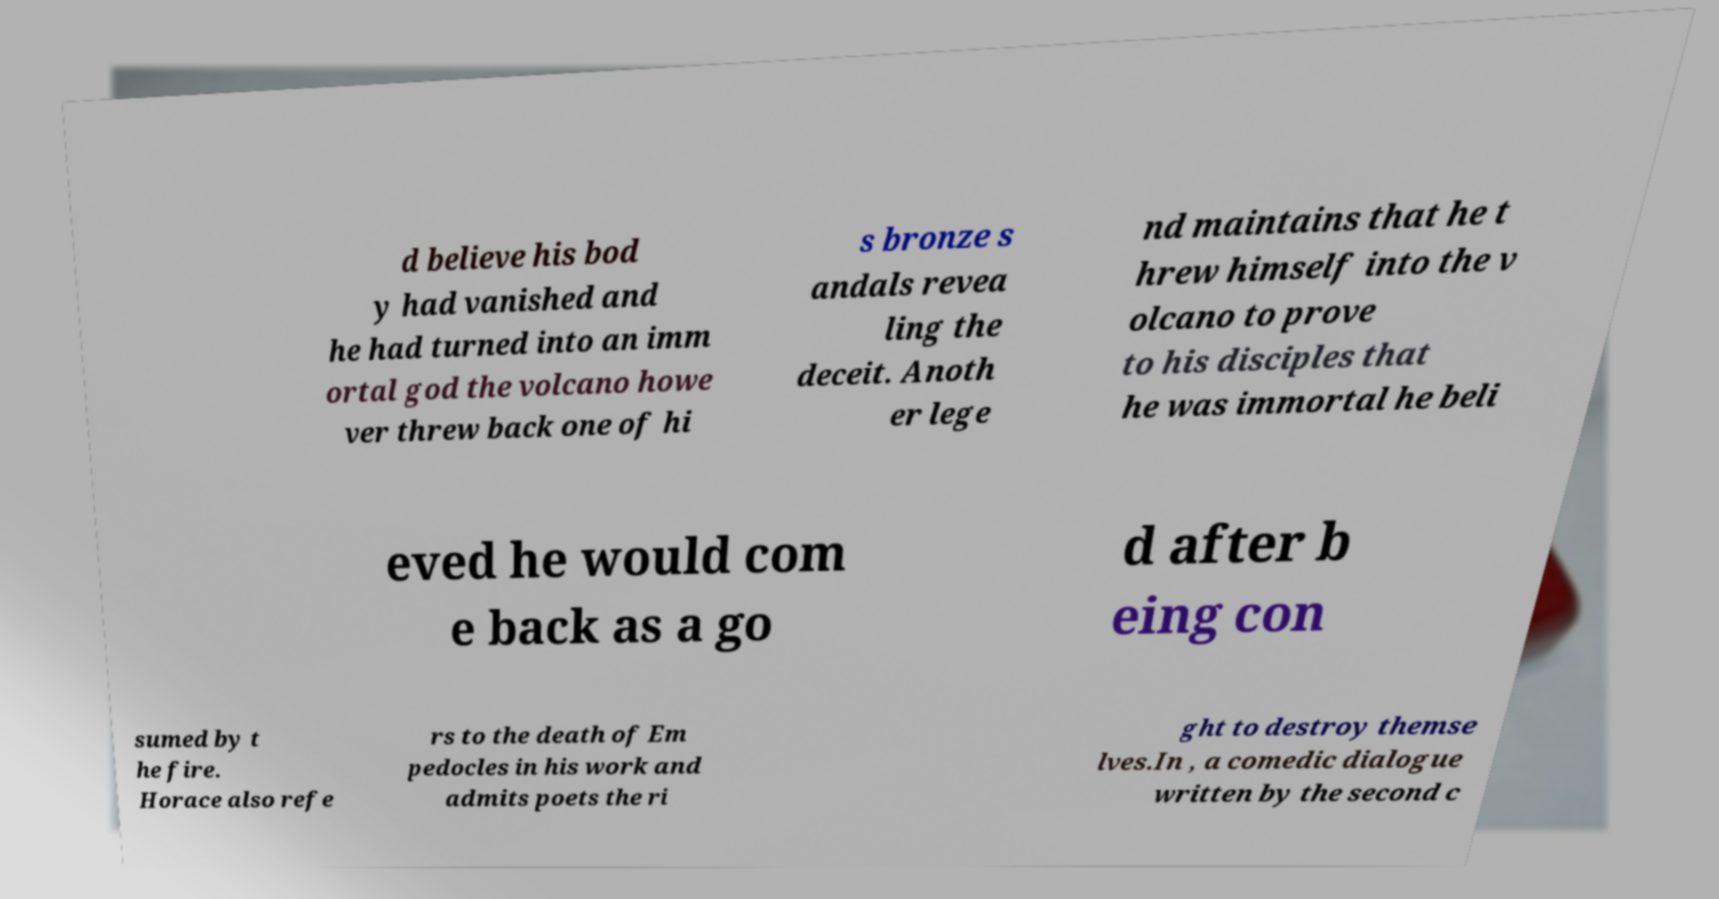I need the written content from this picture converted into text. Can you do that? d believe his bod y had vanished and he had turned into an imm ortal god the volcano howe ver threw back one of hi s bronze s andals revea ling the deceit. Anoth er lege nd maintains that he t hrew himself into the v olcano to prove to his disciples that he was immortal he beli eved he would com e back as a go d after b eing con sumed by t he fire. Horace also refe rs to the death of Em pedocles in his work and admits poets the ri ght to destroy themse lves.In , a comedic dialogue written by the second c 